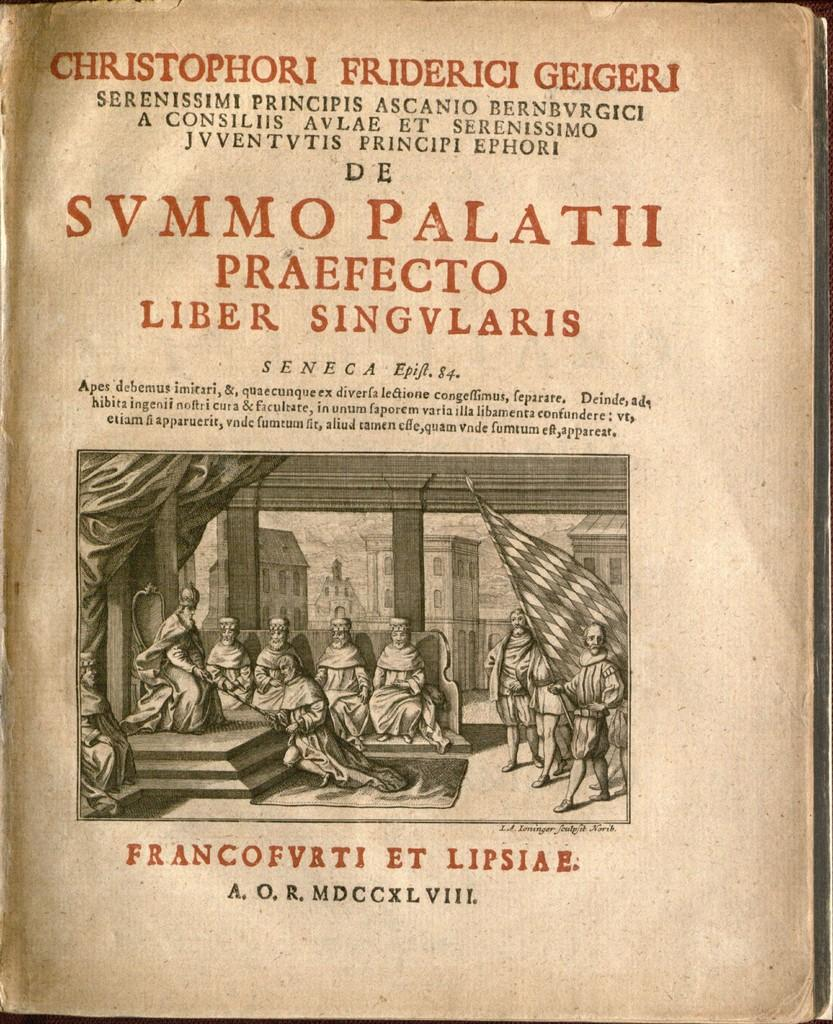<image>
Share a concise interpretation of the image provided. The book shown is written by the author Christophori Frierici Geigeri. 